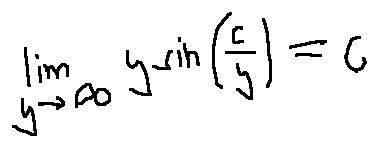Convert formula to latex. <formula><loc_0><loc_0><loc_500><loc_500>\lim \lim i t s _ { y \rightarrow \infty } y \sin ( \frac { c } { y } ) = c</formula> 